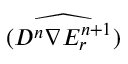<formula> <loc_0><loc_0><loc_500><loc_500>\widehat { ( D ^ { n } \nabla E _ { r } ^ { n + 1 } ) }</formula> 